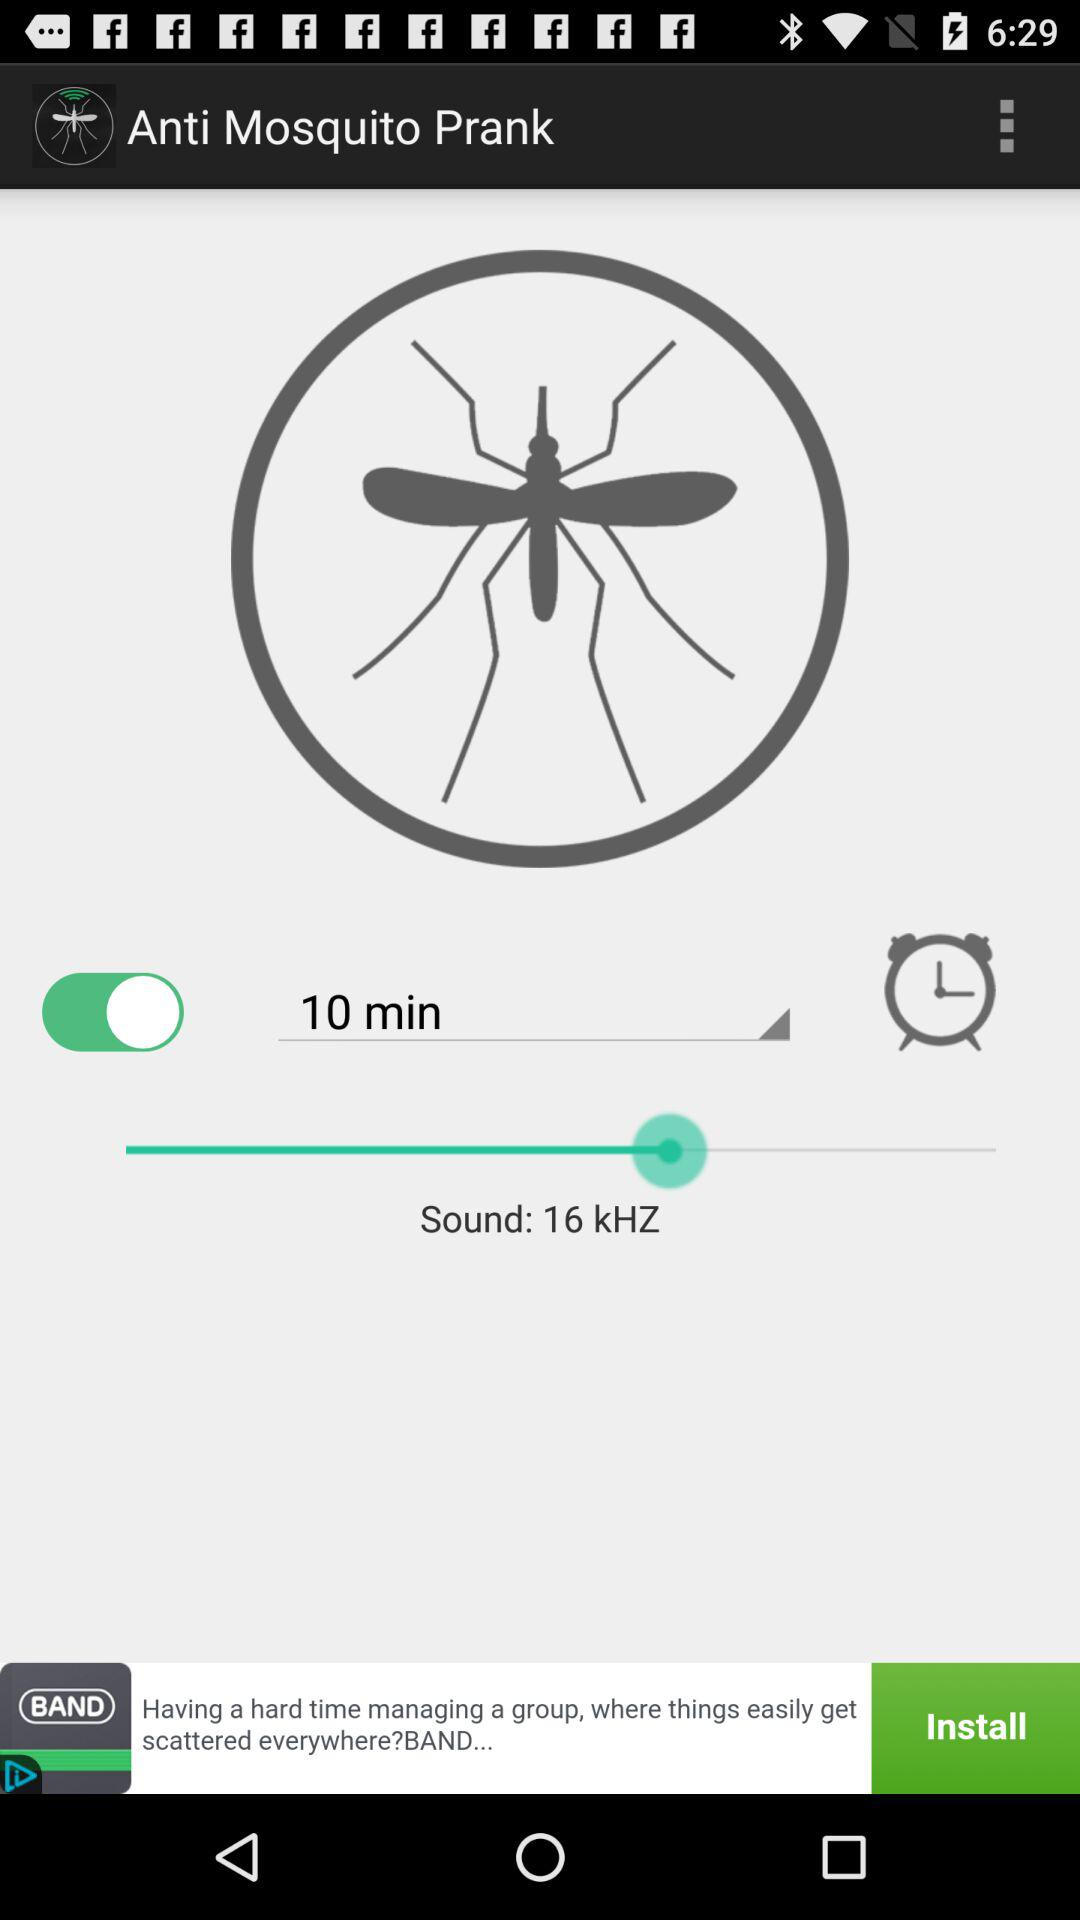What is the sound frequency? The sound frequency is 16 kHz. 